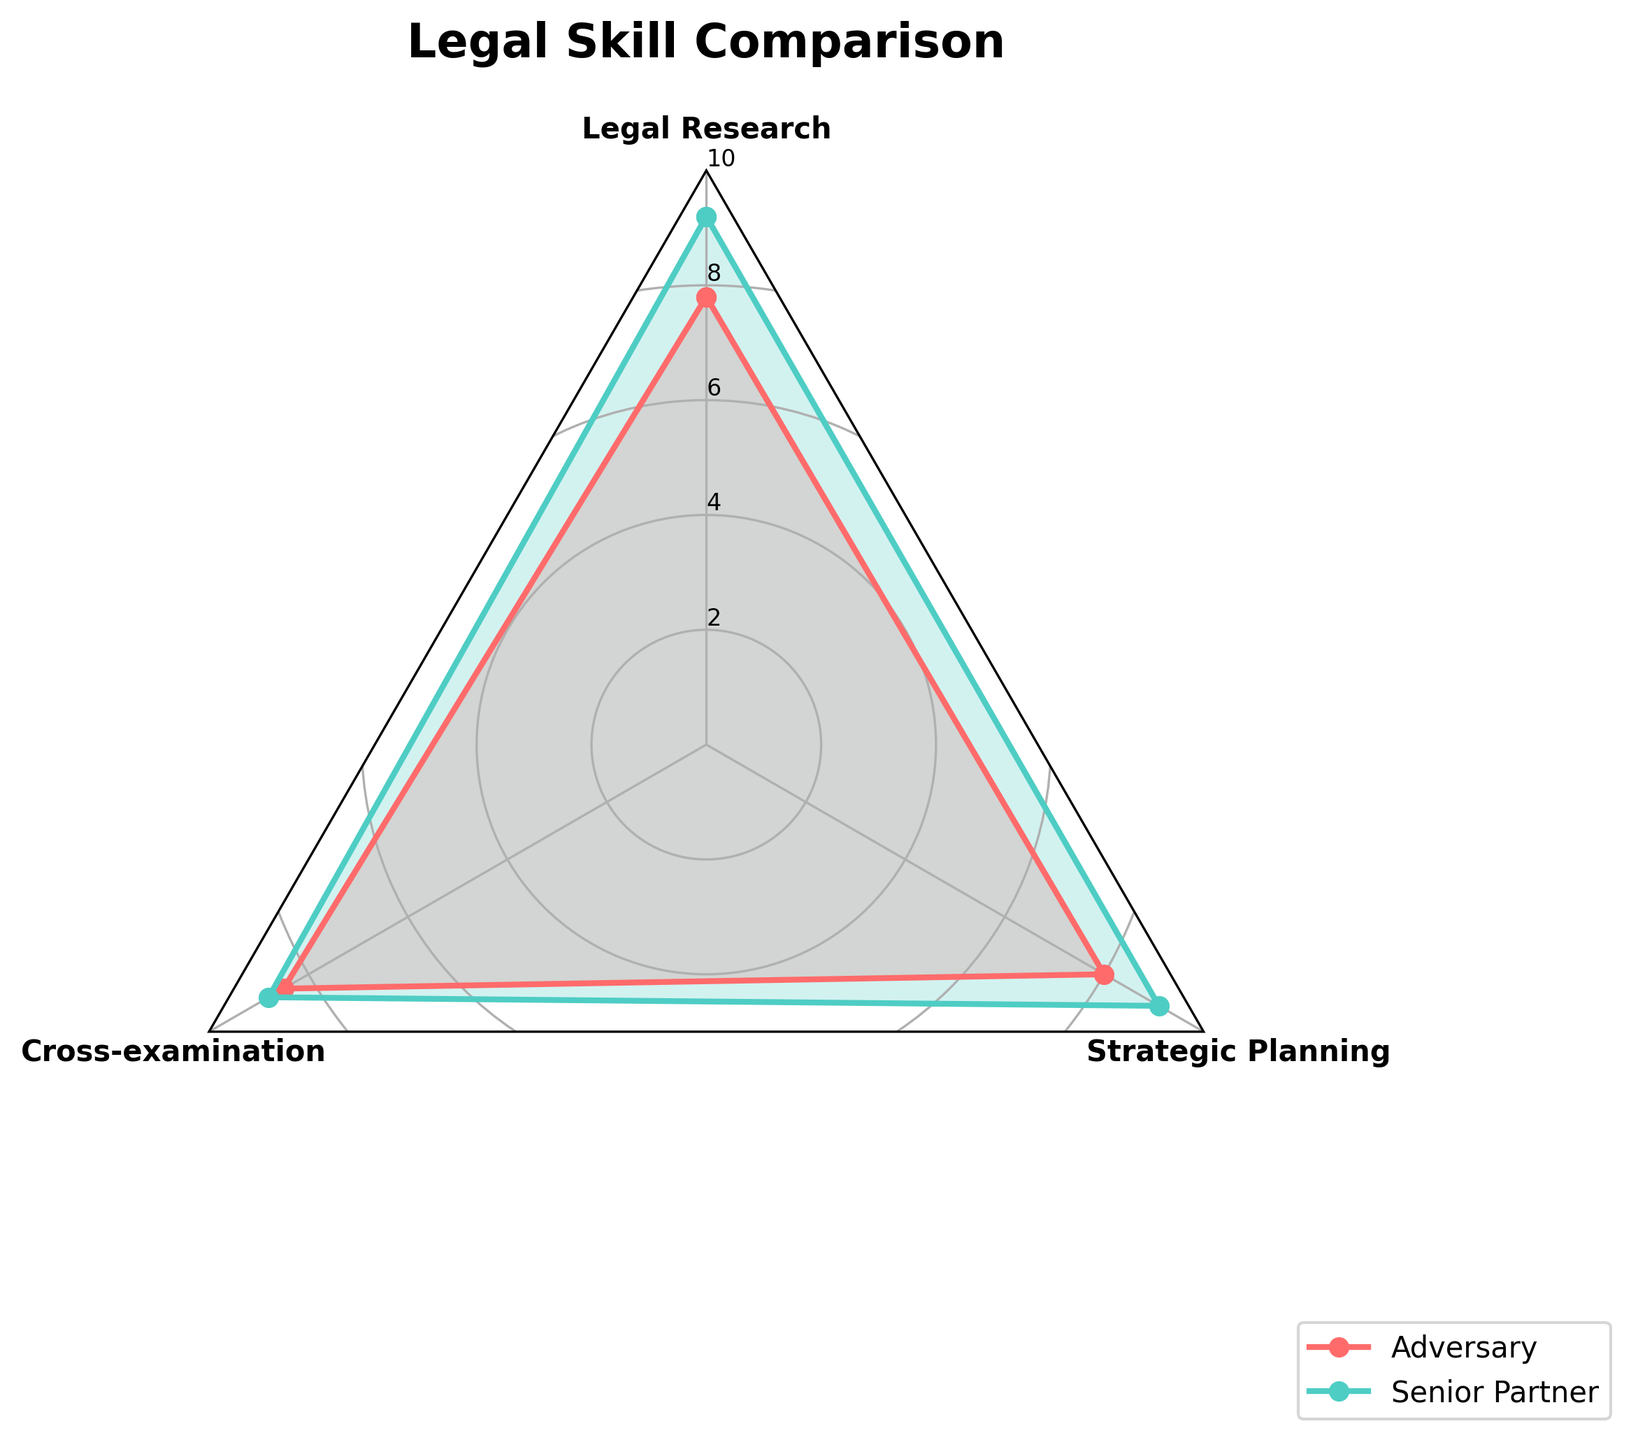Which skill do both the Adversary and Senior Partner have the highest proficiency in? To find the skill with the highest proficiency for both, we look at each group's highest values on the radar chart. Both the Adversary and the Senior Partner have the highest proficiency in Cross-examination, with scores of 8.5 and 8.8 respectively.
Answer: Cross-examination Which skill shows the largest difference in proficiency between the Adversary and the Senior Partner? To determine the largest difference, we calculate the absolute differences for each skill: Legal Research (1.4), Cross-examination (0.3), and Strategic Planning (1.1). The largest difference is in Legal Research.
Answer: Legal Research What is the sum of the Adversary's proficiencies across all skills? The sum of the Adversary's proficiency scores is calculated by adding 7.8 (Legal Research), 8.5 (Cross-examination), and 8.0 (Strategic Planning). So, 7.8 + 8.5 + 8.0 = 24.3.
Answer: 24.3 Which skill does the Senior Partner excel in the most compared to the Adversary? By comparing the differences in proficiency for each skill, we find that Legal Research has the greatest difference (1.4) in favor of the Senior Partner.
Answer: Legal Research Are the Senior Partner's proficiency scores consistently higher than the Adversary's across all skills? Yes, to determine consistency, we compare each skill's proficiency score. The Senior Partner's scores are higher for all skills: Legal Research (9.2 > 7.8), Cross-examination (8.8 > 8.5), and Strategic Planning (9.1 > 8.0).
Answer: Yes What is the average proficiency score for the Senior Partner across all skills? The average is found by adding all of the Senior Partner's proficiency scores and dividing by the number of skills: (9.2 + 8.8 + 9.1) / 3 = 27.1 / 3 ≈ 9.03.
Answer: 9.03 Compare the Adversary and Senior Partner in terms of Cross-examination skills. Who performs better and by how much? The Adversary has a Cross-examination score of 8.5, while the Senior Partner has 8.8. The Senior Partner outperforms the Adversary by 8.8 - 8.5 = 0.3.
Answer: Senior Partner by 0.3 What is the weakest skill for both the Adversary and Senior Partner? By identifying the lowest scores for each, we see that the weakest skill for the Adversary is Legal Research (7.8), and for the Senior Partner, it is Cross-examination (8.8).
Answer: Legal Research for Adversary, Cross-examination for Senior Partner Does any skill show an equal proficiency for both the Adversary and the Senior Partner? By comparing the proficiency scores for all skills, we see no skills have equal proficiency values between the Adversary and Senior Partner.
Answer: No Overall, who has a higher average proficiency, the Adversary or the Senior Partner? We calculate the average proficiency for both. The Adversary's average is (7.8 + 8.5 + 8.0) / 3 = 8.1. The Senior Partner's average is (9.2 + 8.8 + 9.1) / 3 ≈ 9.03. The Senior Partner has a higher average proficiency.
Answer: Senior Partner 